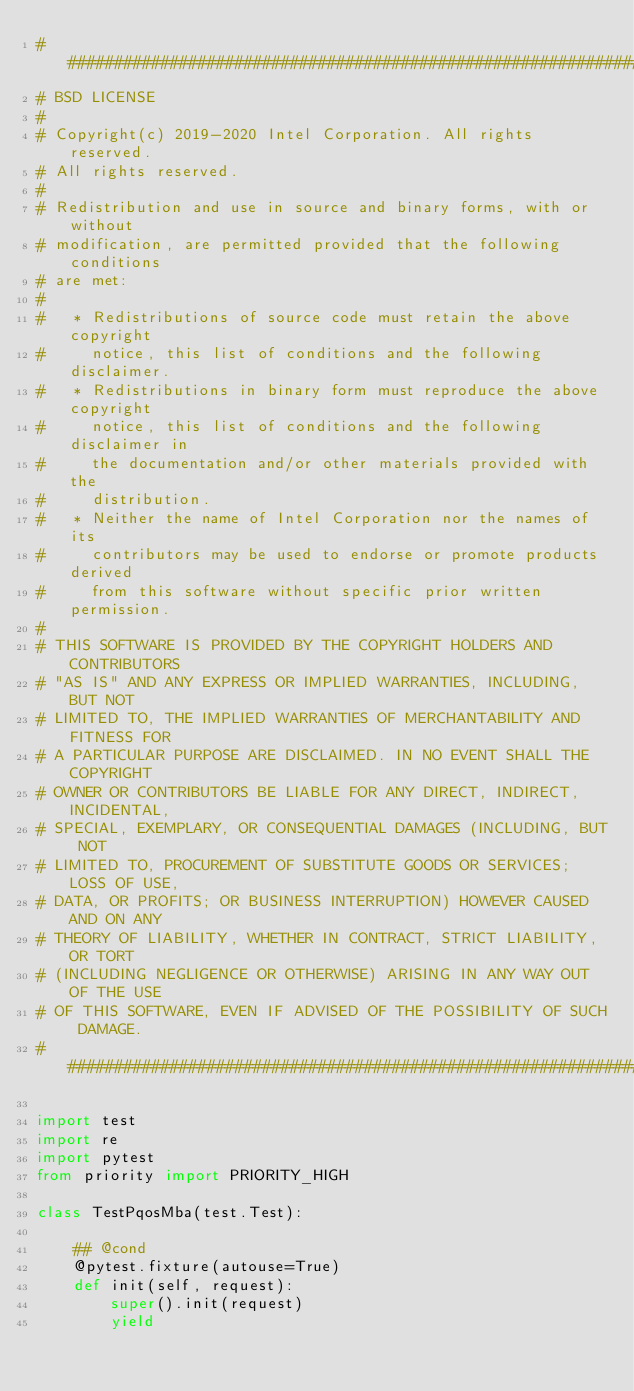<code> <loc_0><loc_0><loc_500><loc_500><_Python_>################################################################################
# BSD LICENSE
#
# Copyright(c) 2019-2020 Intel Corporation. All rights reserved.
# All rights reserved.
#
# Redistribution and use in source and binary forms, with or without
# modification, are permitted provided that the following conditions
# are met:
#
#   * Redistributions of source code must retain the above copyright
#     notice, this list of conditions and the following disclaimer.
#   * Redistributions in binary form must reproduce the above copyright
#     notice, this list of conditions and the following disclaimer in
#     the documentation and/or other materials provided with the
#     distribution.
#   * Neither the name of Intel Corporation nor the names of its
#     contributors may be used to endorse or promote products derived
#     from this software without specific prior written permission.
#
# THIS SOFTWARE IS PROVIDED BY THE COPYRIGHT HOLDERS AND CONTRIBUTORS
# "AS IS" AND ANY EXPRESS OR IMPLIED WARRANTIES, INCLUDING, BUT NOT
# LIMITED TO, THE IMPLIED WARRANTIES OF MERCHANTABILITY AND FITNESS FOR
# A PARTICULAR PURPOSE ARE DISCLAIMED. IN NO EVENT SHALL THE COPYRIGHT
# OWNER OR CONTRIBUTORS BE LIABLE FOR ANY DIRECT, INDIRECT, INCIDENTAL,
# SPECIAL, EXEMPLARY, OR CONSEQUENTIAL DAMAGES (INCLUDING, BUT NOT
# LIMITED TO, PROCUREMENT OF SUBSTITUTE GOODS OR SERVICES; LOSS OF USE,
# DATA, OR PROFITS; OR BUSINESS INTERRUPTION) HOWEVER CAUSED AND ON ANY
# THEORY OF LIABILITY, WHETHER IN CONTRACT, STRICT LIABILITY, OR TORT
# (INCLUDING NEGLIGENCE OR OTHERWISE) ARISING IN ANY WAY OUT OF THE USE
# OF THIS SOFTWARE, EVEN IF ADVISED OF THE POSSIBILITY OF SUCH DAMAGE.
################################################################################

import test
import re
import pytest
from priority import PRIORITY_HIGH

class TestPqosMba(test.Test):

    ## @cond
    @pytest.fixture(autouse=True)
    def init(self, request):
        super().init(request)
        yield</code> 